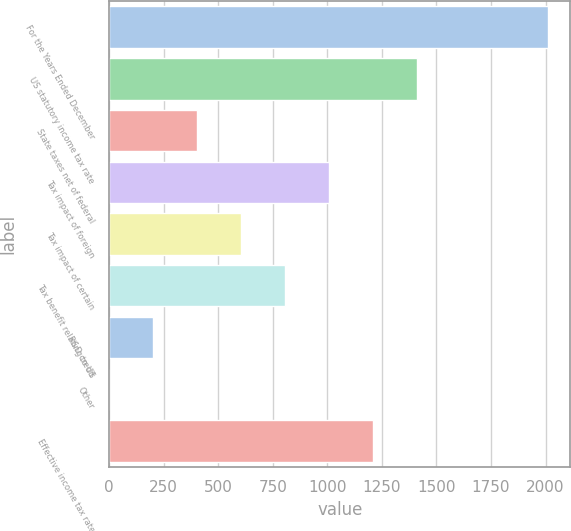Convert chart to OTSL. <chart><loc_0><loc_0><loc_500><loc_500><bar_chart><fcel>For the Years Ended December<fcel>US statutory income tax rate<fcel>State taxes net of federal<fcel>Tax impact of foreign<fcel>Tax impact of certain<fcel>Tax benefit relating to US<fcel>R&D credit<fcel>Other<fcel>Effective income tax rate<nl><fcel>2013<fcel>1409.13<fcel>402.68<fcel>1006.55<fcel>603.97<fcel>805.26<fcel>201.39<fcel>0.1<fcel>1207.84<nl></chart> 